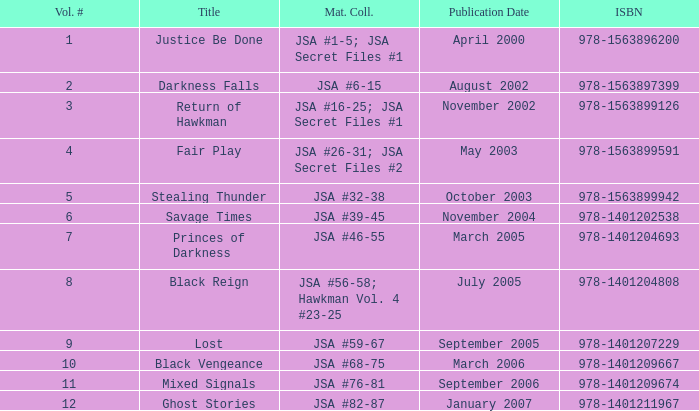I'm looking to parse the entire table for insights. Could you assist me with that? {'header': ['Vol. #', 'Title', 'Mat. Coll.', 'Publication Date', 'ISBN'], 'rows': [['1', 'Justice Be Done', 'JSA #1-5; JSA Secret Files #1', 'April 2000', '978-1563896200'], ['2', 'Darkness Falls', 'JSA #6-15', 'August 2002', '978-1563897399'], ['3', 'Return of Hawkman', 'JSA #16-25; JSA Secret Files #1', 'November 2002', '978-1563899126'], ['4', 'Fair Play', 'JSA #26-31; JSA Secret Files #2', 'May 2003', '978-1563899591'], ['5', 'Stealing Thunder', 'JSA #32-38', 'October 2003', '978-1563899942'], ['6', 'Savage Times', 'JSA #39-45', 'November 2004', '978-1401202538'], ['7', 'Princes of Darkness', 'JSA #46-55', 'March 2005', '978-1401204693'], ['8', 'Black Reign', 'JSA #56-58; Hawkman Vol. 4 #23-25', 'July 2005', '978-1401204808'], ['9', 'Lost', 'JSA #59-67', 'September 2005', '978-1401207229'], ['10', 'Black Vengeance', 'JSA #68-75', 'March 2006', '978-1401209667'], ['11', 'Mixed Signals', 'JSA #76-81', 'September 2006', '978-1401209674'], ['12', 'Ghost Stories', 'JSA #82-87', 'January 2007', '978-1401211967']]} What is the count of volume numbers for the title darkness falls? 2.0. 